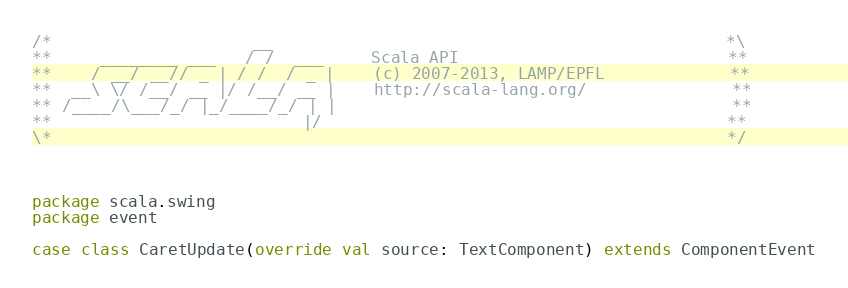Convert code to text. <code><loc_0><loc_0><loc_500><loc_500><_Scala_>/*                     __                                               *\
**     ________ ___   / /  ___     Scala API                            **
**    / __/ __// _ | / /  / _ |    (c) 2007-2013, LAMP/EPFL             **
**  __\ \/ /__/ __ |/ /__/ __ |    http://scala-lang.org/               **
** /____/\___/_/ |_/____/_/ | |                                         **
**                          |/                                          **
\*                                                                      */



package scala.swing
package event

case class CaretUpdate(override val source: TextComponent) extends ComponentEvent
</code> 